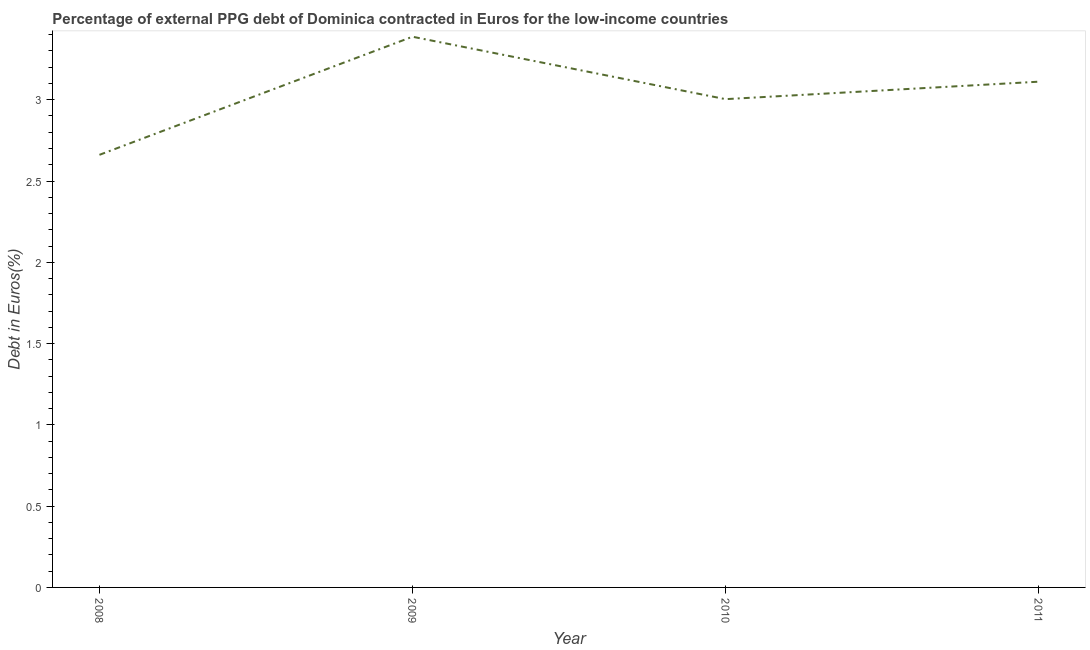What is the currency composition of ppg debt in 2009?
Keep it short and to the point. 3.39. Across all years, what is the maximum currency composition of ppg debt?
Offer a very short reply. 3.39. Across all years, what is the minimum currency composition of ppg debt?
Ensure brevity in your answer.  2.66. In which year was the currency composition of ppg debt minimum?
Your answer should be very brief. 2008. What is the sum of the currency composition of ppg debt?
Keep it short and to the point. 12.16. What is the difference between the currency composition of ppg debt in 2008 and 2009?
Provide a succinct answer. -0.73. What is the average currency composition of ppg debt per year?
Your answer should be very brief. 3.04. What is the median currency composition of ppg debt?
Your answer should be very brief. 3.06. In how many years, is the currency composition of ppg debt greater than 2.3 %?
Your answer should be very brief. 4. Do a majority of the years between 2009 and 2008 (inclusive) have currency composition of ppg debt greater than 2.2 %?
Make the answer very short. No. What is the ratio of the currency composition of ppg debt in 2009 to that in 2011?
Ensure brevity in your answer.  1.09. Is the currency composition of ppg debt in 2010 less than that in 2011?
Your response must be concise. Yes. What is the difference between the highest and the second highest currency composition of ppg debt?
Your answer should be compact. 0.28. What is the difference between the highest and the lowest currency composition of ppg debt?
Offer a terse response. 0.73. How many lines are there?
Provide a succinct answer. 1. How many years are there in the graph?
Your answer should be compact. 4. Does the graph contain any zero values?
Provide a succinct answer. No. Does the graph contain grids?
Your answer should be very brief. No. What is the title of the graph?
Provide a succinct answer. Percentage of external PPG debt of Dominica contracted in Euros for the low-income countries. What is the label or title of the X-axis?
Provide a succinct answer. Year. What is the label or title of the Y-axis?
Make the answer very short. Debt in Euros(%). What is the Debt in Euros(%) of 2008?
Give a very brief answer. 2.66. What is the Debt in Euros(%) of 2009?
Offer a terse response. 3.39. What is the Debt in Euros(%) in 2010?
Ensure brevity in your answer.  3. What is the Debt in Euros(%) in 2011?
Your answer should be very brief. 3.11. What is the difference between the Debt in Euros(%) in 2008 and 2009?
Give a very brief answer. -0.73. What is the difference between the Debt in Euros(%) in 2008 and 2010?
Your answer should be compact. -0.34. What is the difference between the Debt in Euros(%) in 2008 and 2011?
Ensure brevity in your answer.  -0.45. What is the difference between the Debt in Euros(%) in 2009 and 2010?
Keep it short and to the point. 0.38. What is the difference between the Debt in Euros(%) in 2009 and 2011?
Give a very brief answer. 0.28. What is the difference between the Debt in Euros(%) in 2010 and 2011?
Provide a short and direct response. -0.11. What is the ratio of the Debt in Euros(%) in 2008 to that in 2009?
Your answer should be very brief. 0.79. What is the ratio of the Debt in Euros(%) in 2008 to that in 2010?
Give a very brief answer. 0.89. What is the ratio of the Debt in Euros(%) in 2008 to that in 2011?
Provide a succinct answer. 0.85. What is the ratio of the Debt in Euros(%) in 2009 to that in 2010?
Ensure brevity in your answer.  1.13. What is the ratio of the Debt in Euros(%) in 2009 to that in 2011?
Provide a short and direct response. 1.09. 